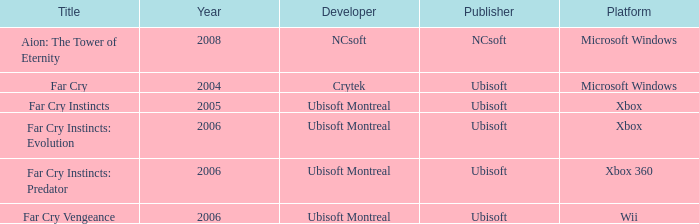What is the average year that has far cry vengeance as the title? 2006.0. 